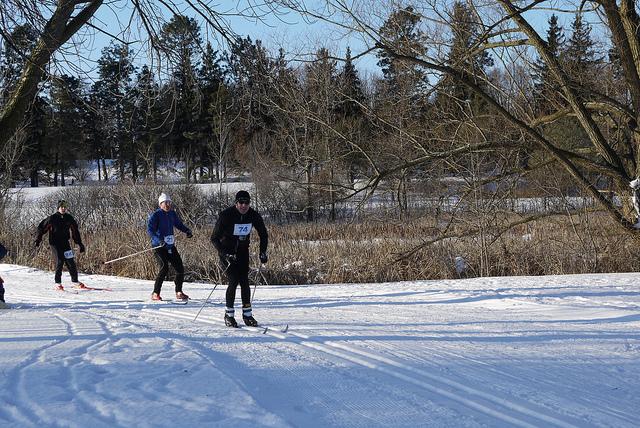How many skiers are in the picture?
Write a very short answer. 3. What kind of skiing are they doing?
Concise answer only. Cross country. Is there any trees in the background?
Give a very brief answer. Yes. 